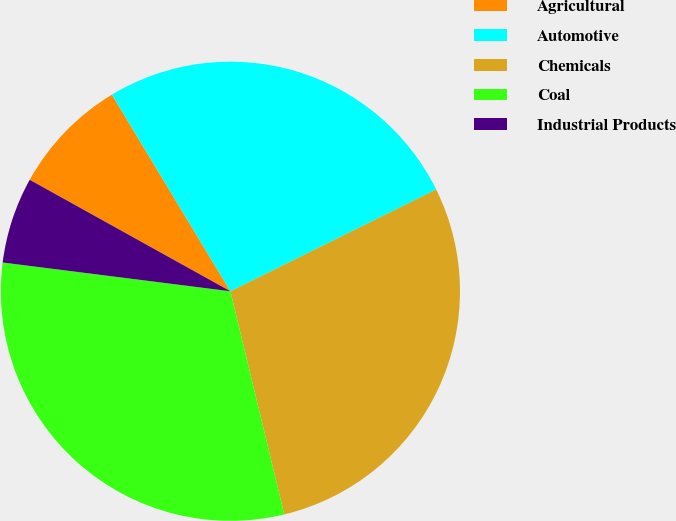<chart> <loc_0><loc_0><loc_500><loc_500><pie_chart><fcel>Agricultural<fcel>Automotive<fcel>Chemicals<fcel>Coal<fcel>Industrial Products<nl><fcel>8.3%<fcel>26.32%<fcel>28.54%<fcel>30.77%<fcel>6.07%<nl></chart> 